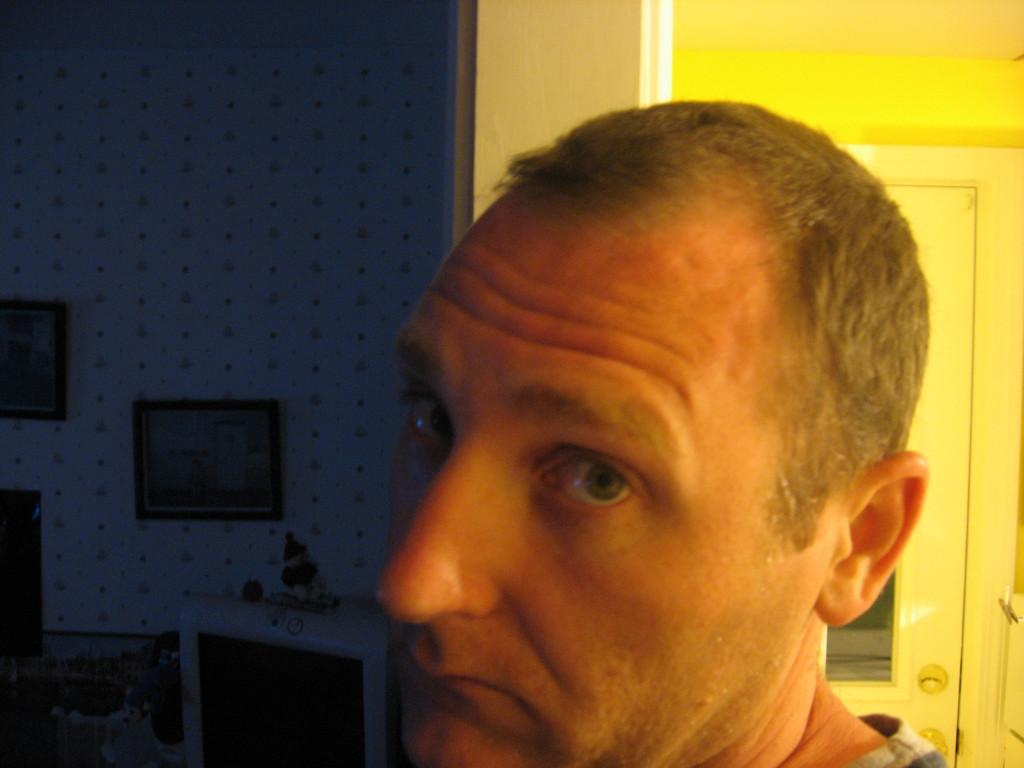What is the main subject of the image? There is a person's face in the image. What can be seen on the wall in the image? There are frames attached to the wall in the image. Is there any entrance or exit visible in the image? Yes, there is a door in the image. What type of ice can be seen melting on the person's face in the image? There is no ice present on the person's face in the image. What agreement was reached between the person and the wall in the image? There is no agreement mentioned or implied in the image. 